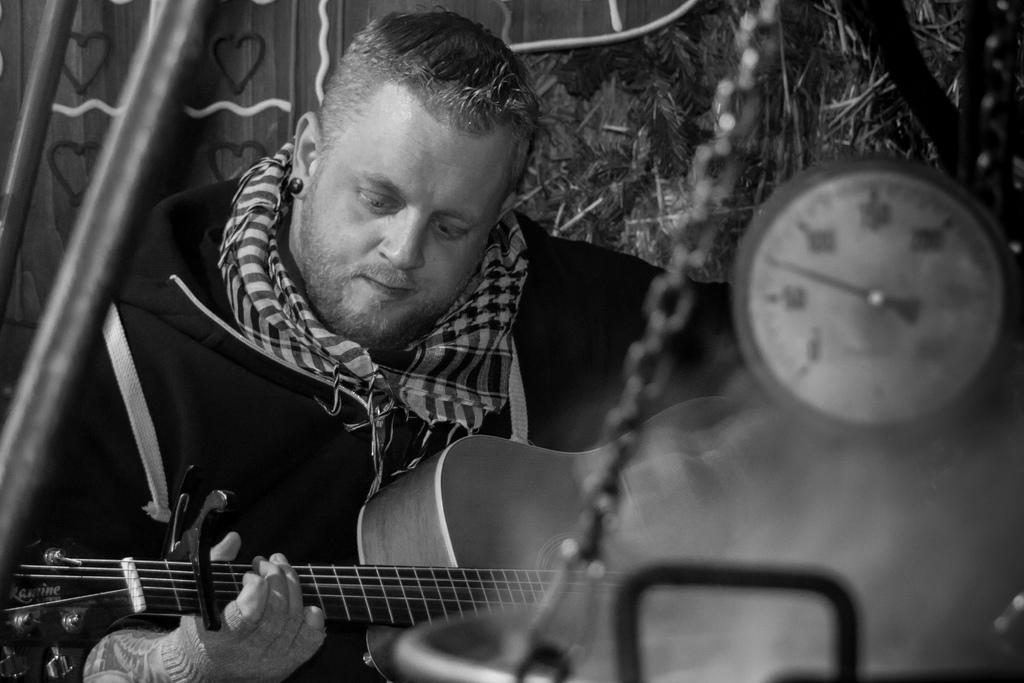What is the main subject of the image? The main subject of the image is a musician. What is the musician doing in the image? The musician is holding and playing a musical instrument. What can be seen at the right side of the image? There is a timing machine at the right side of the image. What is visible in the background of the image? There is a door and plants in the background of the image. What shape is the flock of birds flying in the image? There are no birds present in the image, so it is not possible to determine the shape of any flock. How does the musician adapt their performance to the winter season in the image? The image does not provide any information about the season or the musician's adaptation to it, so we cannot answer this question. 